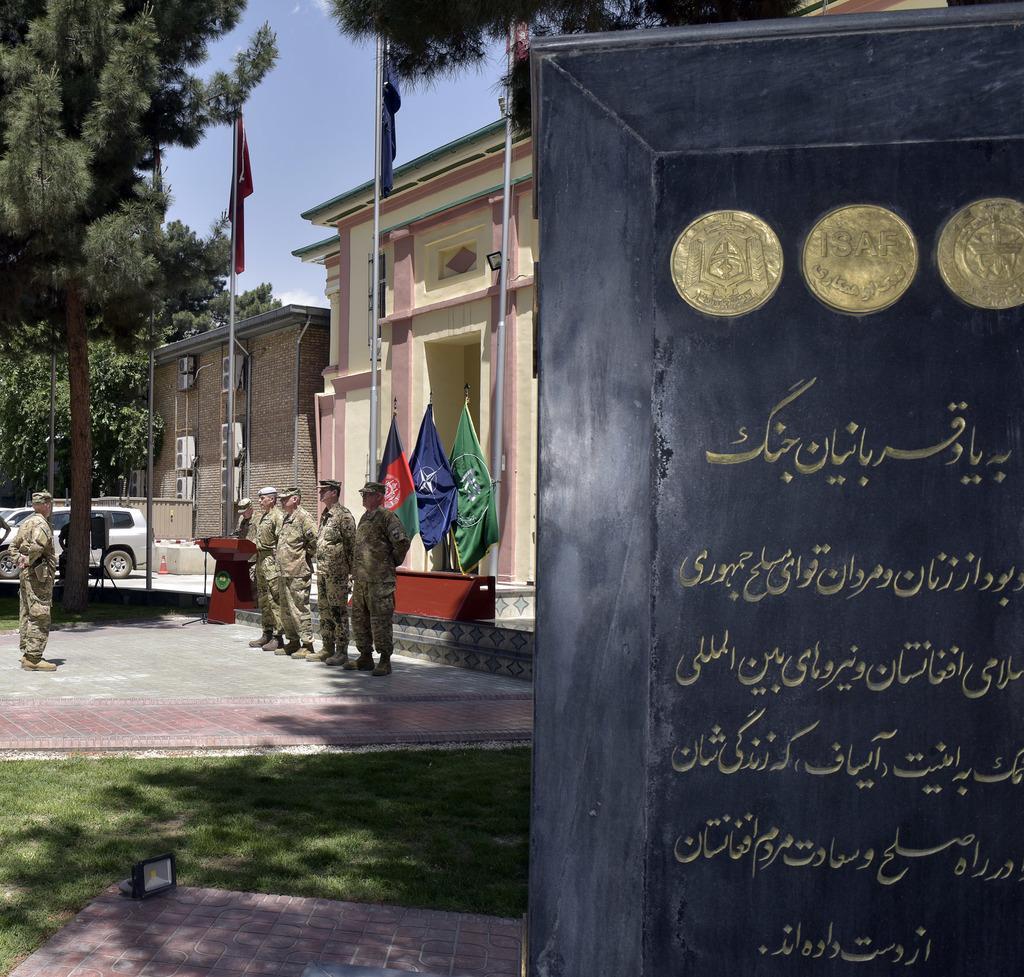Can you describe this image briefly? In this picture i can see a stone memorial on the left side of the picture on the right side of the picture a person standing. He is facing towards the other four persons who are standing in the center of the picture and I can see a building behind the persons standing and I can see three flags just before the building and I can see the top of the picture is sky and I can see two trees at the top of the picture. 